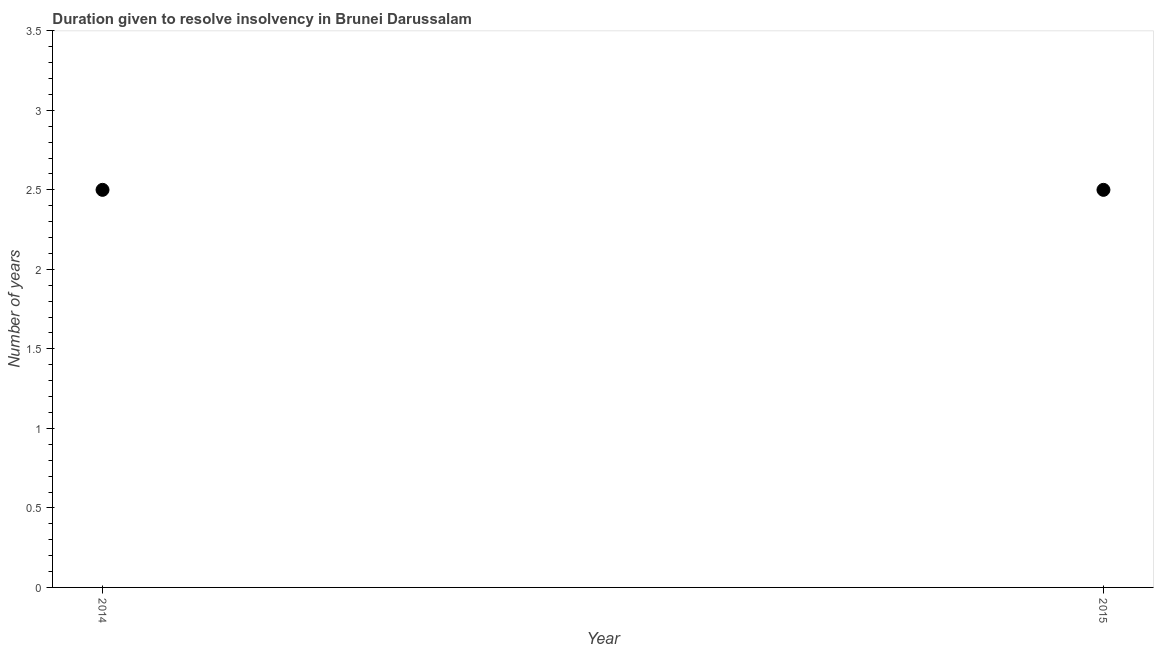What is the number of years to resolve insolvency in 2014?
Your response must be concise. 2.5. Across all years, what is the maximum number of years to resolve insolvency?
Ensure brevity in your answer.  2.5. Across all years, what is the minimum number of years to resolve insolvency?
Give a very brief answer. 2.5. In which year was the number of years to resolve insolvency maximum?
Give a very brief answer. 2014. What is the average number of years to resolve insolvency per year?
Provide a succinct answer. 2.5. In how many years, is the number of years to resolve insolvency greater than 0.1 ?
Provide a short and direct response. 2. What is the ratio of the number of years to resolve insolvency in 2014 to that in 2015?
Your answer should be compact. 1. In how many years, is the number of years to resolve insolvency greater than the average number of years to resolve insolvency taken over all years?
Provide a succinct answer. 0. How many years are there in the graph?
Provide a succinct answer. 2. What is the difference between two consecutive major ticks on the Y-axis?
Your answer should be very brief. 0.5. Are the values on the major ticks of Y-axis written in scientific E-notation?
Provide a succinct answer. No. Does the graph contain any zero values?
Provide a short and direct response. No. What is the title of the graph?
Your answer should be compact. Duration given to resolve insolvency in Brunei Darussalam. What is the label or title of the X-axis?
Ensure brevity in your answer.  Year. What is the label or title of the Y-axis?
Provide a short and direct response. Number of years. What is the Number of years in 2015?
Offer a very short reply. 2.5. What is the difference between the Number of years in 2014 and 2015?
Your response must be concise. 0. What is the ratio of the Number of years in 2014 to that in 2015?
Ensure brevity in your answer.  1. 